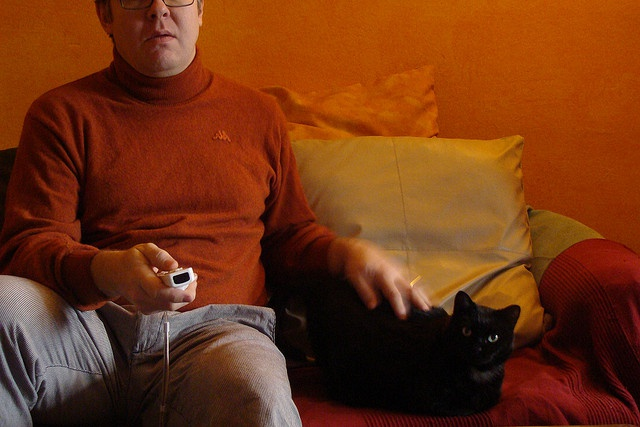Describe the objects in this image and their specific colors. I can see people in maroon, black, and darkgray tones, couch in maroon, red, and black tones, cat in maroon, black, and brown tones, and remote in maroon, black, lightgray, and darkgray tones in this image. 